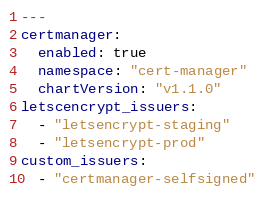<code> <loc_0><loc_0><loc_500><loc_500><_YAML_>---
certmanager:
  enabled: true
  namespace: "cert-manager"
  chartVersion: "v1.1.0"
letscencrypt_issuers:
  - "letsencrypt-staging"
  - "letsencrypt-prod"
custom_issuers:
  - "certmanager-selfsigned"

</code> 